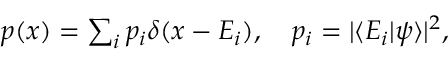Convert formula to latex. <formula><loc_0><loc_0><loc_500><loc_500>\begin{array} { r } { p ( x ) = \sum _ { i } p _ { i } \delta ( x - E _ { i } ) , \quad p _ { i } = | \langle E _ { i } | \psi \rangle | ^ { 2 } , } \end{array}</formula> 